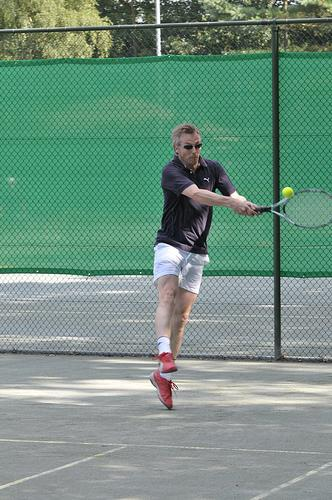Why does the man have his arms out? hitting ball 